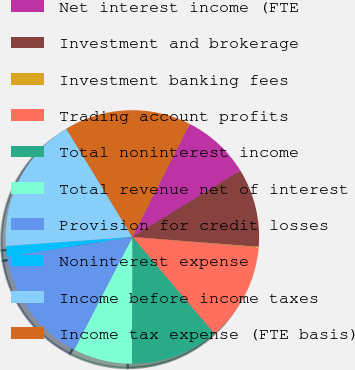Convert chart. <chart><loc_0><loc_0><loc_500><loc_500><pie_chart><fcel>Net interest income (FTE<fcel>Investment and brokerage<fcel>Investment banking fees<fcel>Trading account profits<fcel>Total noninterest income<fcel>Total revenue net of interest<fcel>Provision for credit losses<fcel>Noninterest expense<fcel>Income before income taxes<fcel>Income tax expense (FTE basis)<nl><fcel>8.76%<fcel>10.0%<fcel>0.09%<fcel>12.48%<fcel>11.24%<fcel>7.52%<fcel>14.95%<fcel>1.33%<fcel>17.43%<fcel>16.19%<nl></chart> 